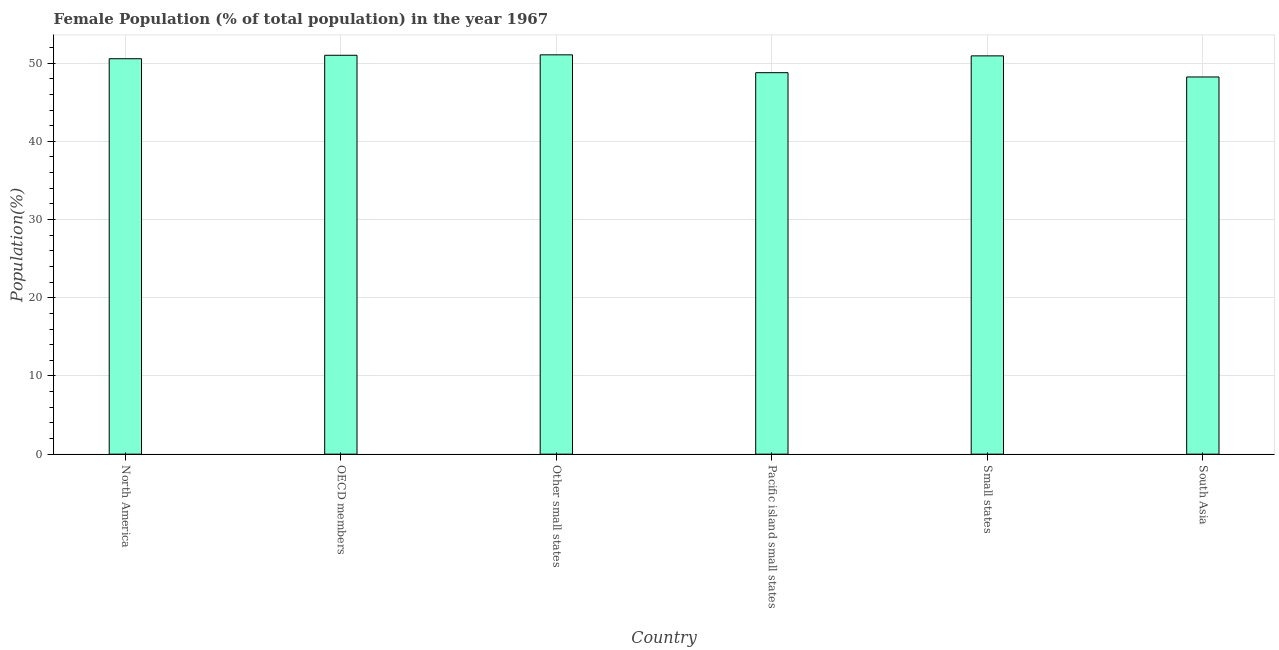Does the graph contain grids?
Keep it short and to the point. Yes. What is the title of the graph?
Offer a terse response. Female Population (% of total population) in the year 1967. What is the label or title of the X-axis?
Provide a short and direct response. Country. What is the label or title of the Y-axis?
Your answer should be very brief. Population(%). What is the female population in Pacific island small states?
Provide a succinct answer. 48.78. Across all countries, what is the maximum female population?
Give a very brief answer. 51.06. Across all countries, what is the minimum female population?
Give a very brief answer. 48.23. In which country was the female population maximum?
Make the answer very short. Other small states. In which country was the female population minimum?
Give a very brief answer. South Asia. What is the sum of the female population?
Ensure brevity in your answer.  300.57. What is the difference between the female population in OECD members and Small states?
Provide a short and direct response. 0.08. What is the average female population per country?
Your answer should be compact. 50.09. What is the median female population?
Your answer should be very brief. 50.75. In how many countries, is the female population greater than 42 %?
Make the answer very short. 6. What is the ratio of the female population in North America to that in Pacific island small states?
Keep it short and to the point. 1.04. Is the female population in Pacific island small states less than that in Small states?
Offer a very short reply. Yes. Is the difference between the female population in Pacific island small states and Small states greater than the difference between any two countries?
Your answer should be compact. No. What is the difference between the highest and the second highest female population?
Your answer should be compact. 0.05. What is the difference between the highest and the lowest female population?
Offer a terse response. 2.83. Are all the bars in the graph horizontal?
Your answer should be very brief. No. How many countries are there in the graph?
Offer a very short reply. 6. What is the difference between two consecutive major ticks on the Y-axis?
Offer a terse response. 10. What is the Population(%) of North America?
Your answer should be very brief. 50.56. What is the Population(%) of OECD members?
Provide a succinct answer. 51. What is the Population(%) in Other small states?
Your answer should be compact. 51.06. What is the Population(%) in Pacific island small states?
Ensure brevity in your answer.  48.78. What is the Population(%) of Small states?
Your answer should be very brief. 50.93. What is the Population(%) of South Asia?
Offer a very short reply. 48.23. What is the difference between the Population(%) in North America and OECD members?
Offer a terse response. -0.44. What is the difference between the Population(%) in North America and Other small states?
Provide a short and direct response. -0.5. What is the difference between the Population(%) in North America and Pacific island small states?
Offer a terse response. 1.78. What is the difference between the Population(%) in North America and Small states?
Your response must be concise. -0.37. What is the difference between the Population(%) in North America and South Asia?
Keep it short and to the point. 2.33. What is the difference between the Population(%) in OECD members and Other small states?
Make the answer very short. -0.05. What is the difference between the Population(%) in OECD members and Pacific island small states?
Your response must be concise. 2.23. What is the difference between the Population(%) in OECD members and Small states?
Provide a succinct answer. 0.08. What is the difference between the Population(%) in OECD members and South Asia?
Provide a succinct answer. 2.77. What is the difference between the Population(%) in Other small states and Pacific island small states?
Your response must be concise. 2.28. What is the difference between the Population(%) in Other small states and Small states?
Your response must be concise. 0.13. What is the difference between the Population(%) in Other small states and South Asia?
Provide a succinct answer. 2.83. What is the difference between the Population(%) in Pacific island small states and Small states?
Provide a short and direct response. -2.15. What is the difference between the Population(%) in Pacific island small states and South Asia?
Give a very brief answer. 0.55. What is the difference between the Population(%) in Small states and South Asia?
Your response must be concise. 2.7. What is the ratio of the Population(%) in North America to that in Other small states?
Make the answer very short. 0.99. What is the ratio of the Population(%) in North America to that in Small states?
Your response must be concise. 0.99. What is the ratio of the Population(%) in North America to that in South Asia?
Your response must be concise. 1.05. What is the ratio of the Population(%) in OECD members to that in Pacific island small states?
Your response must be concise. 1.05. What is the ratio of the Population(%) in OECD members to that in South Asia?
Offer a terse response. 1.06. What is the ratio of the Population(%) in Other small states to that in Pacific island small states?
Ensure brevity in your answer.  1.05. What is the ratio of the Population(%) in Other small states to that in South Asia?
Your answer should be very brief. 1.06. What is the ratio of the Population(%) in Pacific island small states to that in Small states?
Offer a very short reply. 0.96. What is the ratio of the Population(%) in Pacific island small states to that in South Asia?
Ensure brevity in your answer.  1.01. What is the ratio of the Population(%) in Small states to that in South Asia?
Your answer should be very brief. 1.06. 